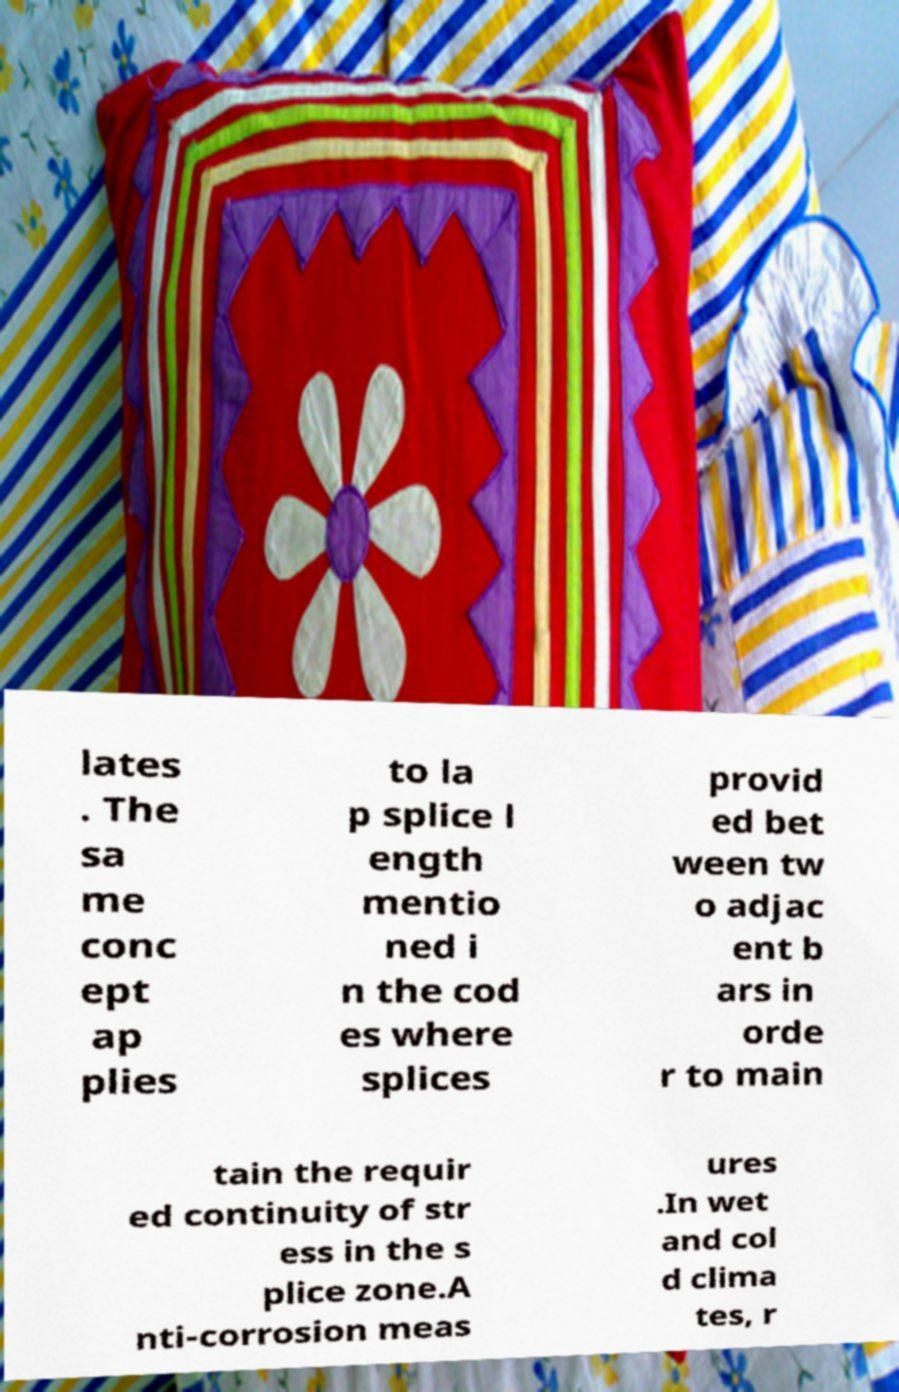Please identify and transcribe the text found in this image. lates . The sa me conc ept ap plies to la p splice l ength mentio ned i n the cod es where splices provid ed bet ween tw o adjac ent b ars in orde r to main tain the requir ed continuity of str ess in the s plice zone.A nti-corrosion meas ures .In wet and col d clima tes, r 